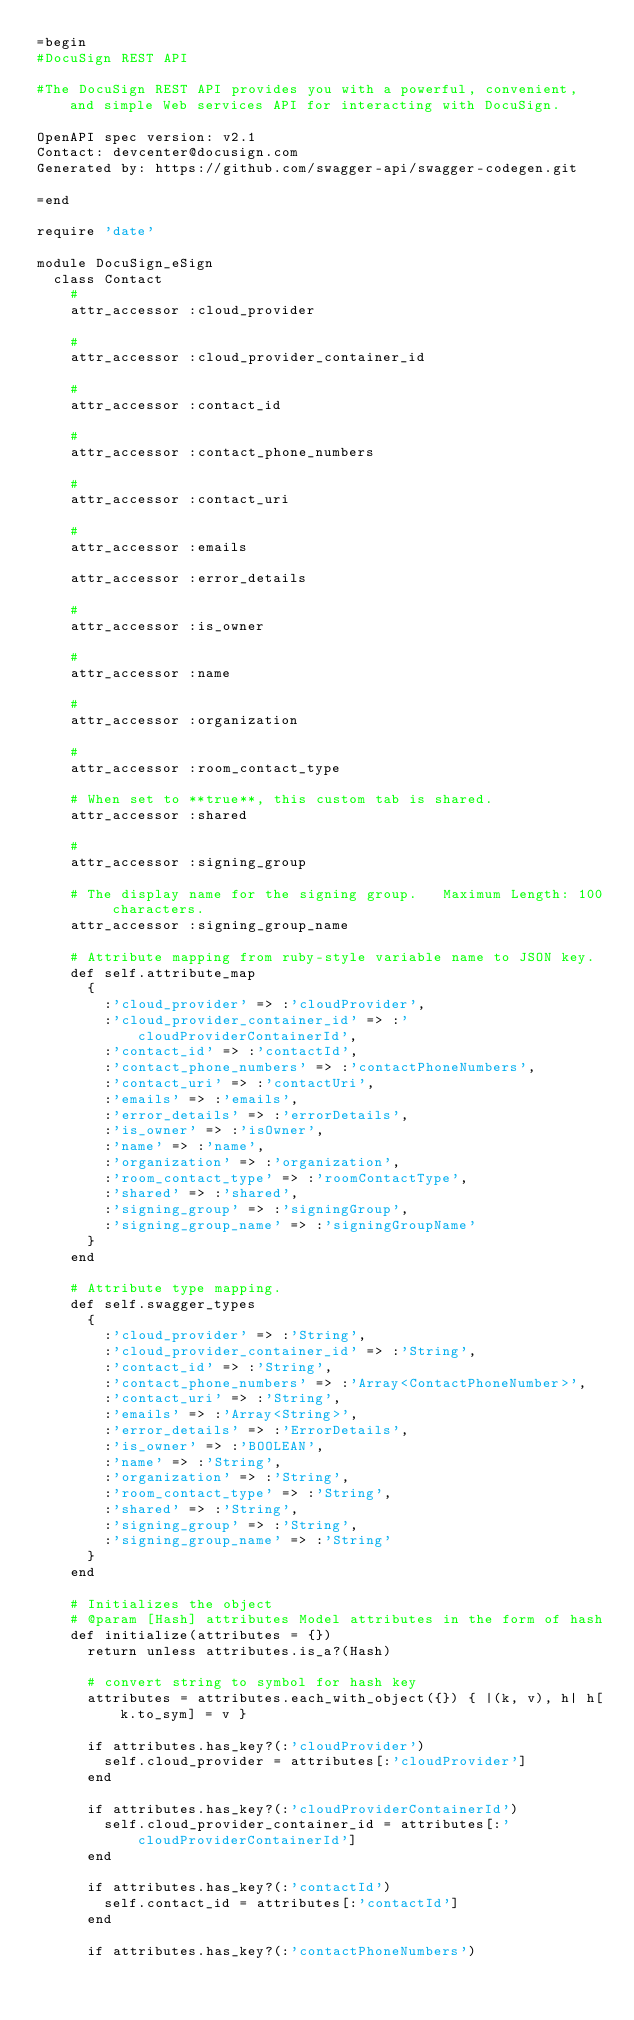<code> <loc_0><loc_0><loc_500><loc_500><_Ruby_>=begin
#DocuSign REST API

#The DocuSign REST API provides you with a powerful, convenient, and simple Web services API for interacting with DocuSign.

OpenAPI spec version: v2.1
Contact: devcenter@docusign.com
Generated by: https://github.com/swagger-api/swagger-codegen.git

=end

require 'date'

module DocuSign_eSign
  class Contact
    # 
    attr_accessor :cloud_provider

    # 
    attr_accessor :cloud_provider_container_id

    # 
    attr_accessor :contact_id

    # 
    attr_accessor :contact_phone_numbers

    # 
    attr_accessor :contact_uri

    # 
    attr_accessor :emails

    attr_accessor :error_details

    # 
    attr_accessor :is_owner

    # 
    attr_accessor :name

    # 
    attr_accessor :organization

    # 
    attr_accessor :room_contact_type

    # When set to **true**, this custom tab is shared.
    attr_accessor :shared

    # 
    attr_accessor :signing_group

    # The display name for the signing group.   Maximum Length: 100 characters. 
    attr_accessor :signing_group_name

    # Attribute mapping from ruby-style variable name to JSON key.
    def self.attribute_map
      {
        :'cloud_provider' => :'cloudProvider',
        :'cloud_provider_container_id' => :'cloudProviderContainerId',
        :'contact_id' => :'contactId',
        :'contact_phone_numbers' => :'contactPhoneNumbers',
        :'contact_uri' => :'contactUri',
        :'emails' => :'emails',
        :'error_details' => :'errorDetails',
        :'is_owner' => :'isOwner',
        :'name' => :'name',
        :'organization' => :'organization',
        :'room_contact_type' => :'roomContactType',
        :'shared' => :'shared',
        :'signing_group' => :'signingGroup',
        :'signing_group_name' => :'signingGroupName'
      }
    end

    # Attribute type mapping.
    def self.swagger_types
      {
        :'cloud_provider' => :'String',
        :'cloud_provider_container_id' => :'String',
        :'contact_id' => :'String',
        :'contact_phone_numbers' => :'Array<ContactPhoneNumber>',
        :'contact_uri' => :'String',
        :'emails' => :'Array<String>',
        :'error_details' => :'ErrorDetails',
        :'is_owner' => :'BOOLEAN',
        :'name' => :'String',
        :'organization' => :'String',
        :'room_contact_type' => :'String',
        :'shared' => :'String',
        :'signing_group' => :'String',
        :'signing_group_name' => :'String'
      }
    end

    # Initializes the object
    # @param [Hash] attributes Model attributes in the form of hash
    def initialize(attributes = {})
      return unless attributes.is_a?(Hash)

      # convert string to symbol for hash key
      attributes = attributes.each_with_object({}) { |(k, v), h| h[k.to_sym] = v }

      if attributes.has_key?(:'cloudProvider')
        self.cloud_provider = attributes[:'cloudProvider']
      end

      if attributes.has_key?(:'cloudProviderContainerId')
        self.cloud_provider_container_id = attributes[:'cloudProviderContainerId']
      end

      if attributes.has_key?(:'contactId')
        self.contact_id = attributes[:'contactId']
      end

      if attributes.has_key?(:'contactPhoneNumbers')</code> 